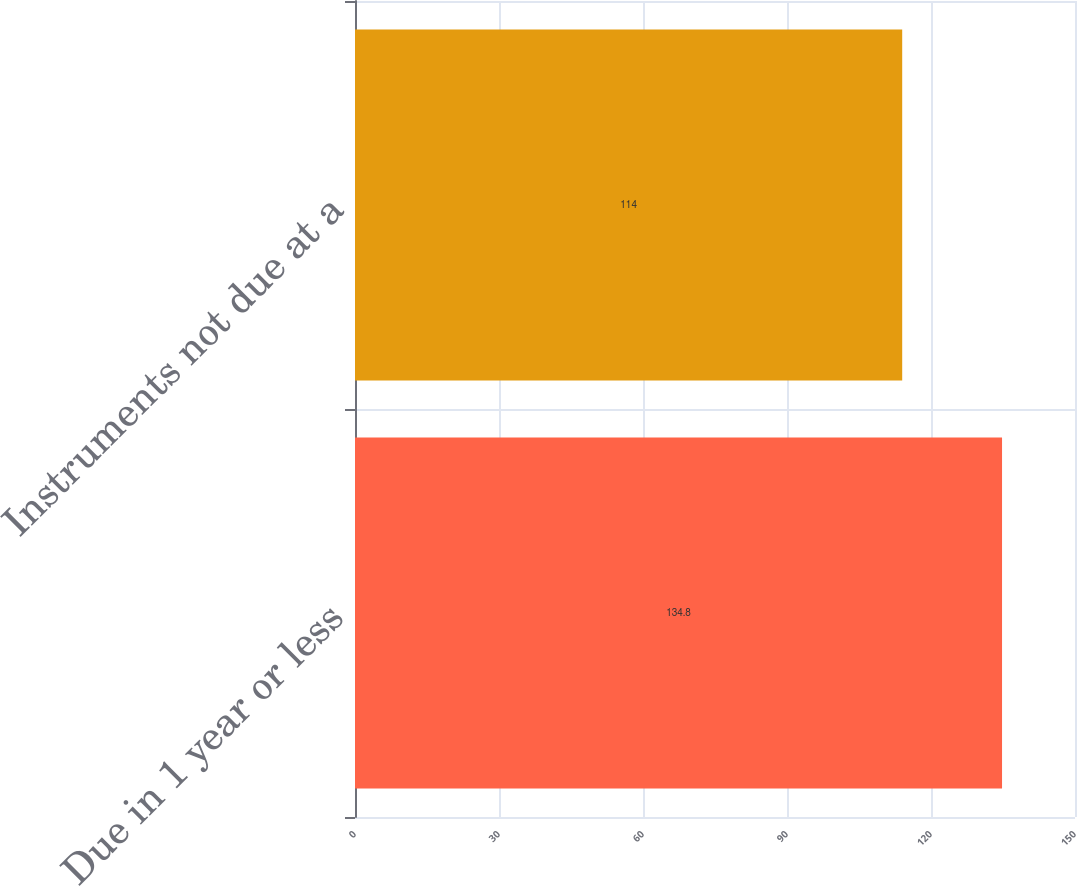Convert chart. <chart><loc_0><loc_0><loc_500><loc_500><bar_chart><fcel>Due in 1 year or less<fcel>Instruments not due at a<nl><fcel>134.8<fcel>114<nl></chart> 